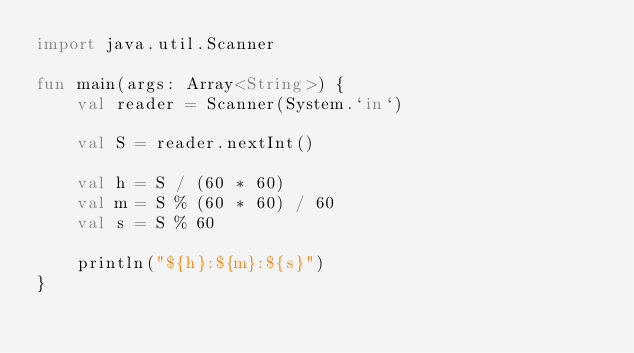<code> <loc_0><loc_0><loc_500><loc_500><_Kotlin_>import java.util.Scanner

fun main(args: Array<String>) {
    val reader = Scanner(System.`in`)
    
    val S = reader.nextInt()
    
    val h = S / (60 * 60)
    val m = S % (60 * 60) / 60
    val s = S % 60

    println("${h}:${m}:${s}")
}
</code> 